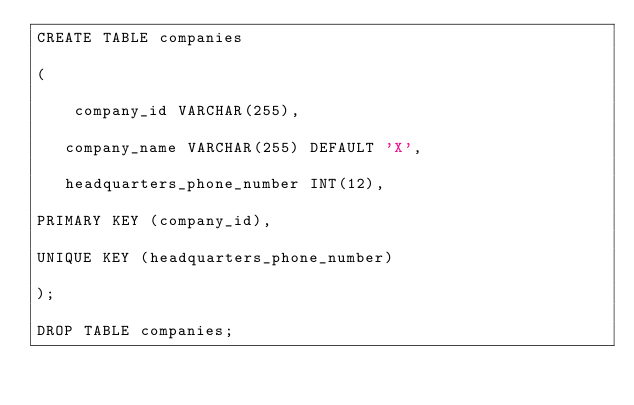<code> <loc_0><loc_0><loc_500><loc_500><_SQL_>CREATE TABLE companies

(

    company_id VARCHAR(255),

   company_name VARCHAR(255) DEFAULT 'X',

   headquarters_phone_number INT(12),

PRIMARY KEY (company_id),

UNIQUE KEY (headquarters_phone_number)

);

DROP TABLE companies;
</code> 